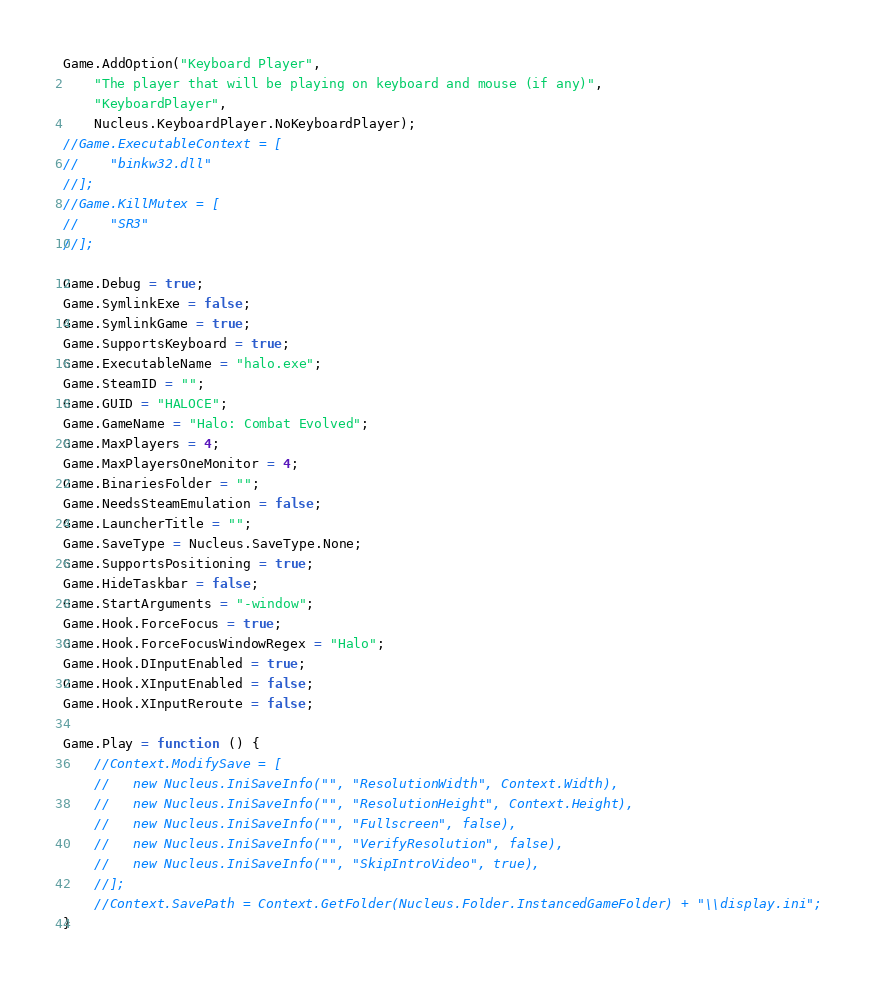Convert code to text. <code><loc_0><loc_0><loc_500><loc_500><_JavaScript_>Game.AddOption("Keyboard Player",
    "The player that will be playing on keyboard and mouse (if any)",
    "KeyboardPlayer",
    Nucleus.KeyboardPlayer.NoKeyboardPlayer);
//Game.ExecutableContext = [
//    "binkw32.dll"
//];
//Game.KillMutex = [
//    "SR3"
//];

Game.Debug = true;
Game.SymlinkExe = false;
Game.SymlinkGame = true;
Game.SupportsKeyboard = true;
Game.ExecutableName = "halo.exe";
Game.SteamID = "";
Game.GUID = "HALOCE";
Game.GameName = "Halo: Combat Evolved";
Game.MaxPlayers = 4;
Game.MaxPlayersOneMonitor = 4;
Game.BinariesFolder = "";
Game.NeedsSteamEmulation = false;
Game.LauncherTitle = "";
Game.SaveType = Nucleus.SaveType.None;
Game.SupportsPositioning = true;
Game.HideTaskbar = false;
Game.StartArguments = "-window";
Game.Hook.ForceFocus = true;
Game.Hook.ForceFocusWindowRegex = "Halo";
Game.Hook.DInputEnabled = true;
Game.Hook.XInputEnabled = false;
Game.Hook.XInputReroute = false;

Game.Play = function () {
    //Context.ModifySave = [
    //   new Nucleus.IniSaveInfo("", "ResolutionWidth", Context.Width),
    //   new Nucleus.IniSaveInfo("", "ResolutionHeight", Context.Height),
    //   new Nucleus.IniSaveInfo("", "Fullscreen", false),
    //   new Nucleus.IniSaveInfo("", "VerifyResolution", false),
    //   new Nucleus.IniSaveInfo("", "SkipIntroVideo", true),
    //];
    //Context.SavePath = Context.GetFolder(Nucleus.Folder.InstancedGameFolder) + "\\display.ini";
}</code> 